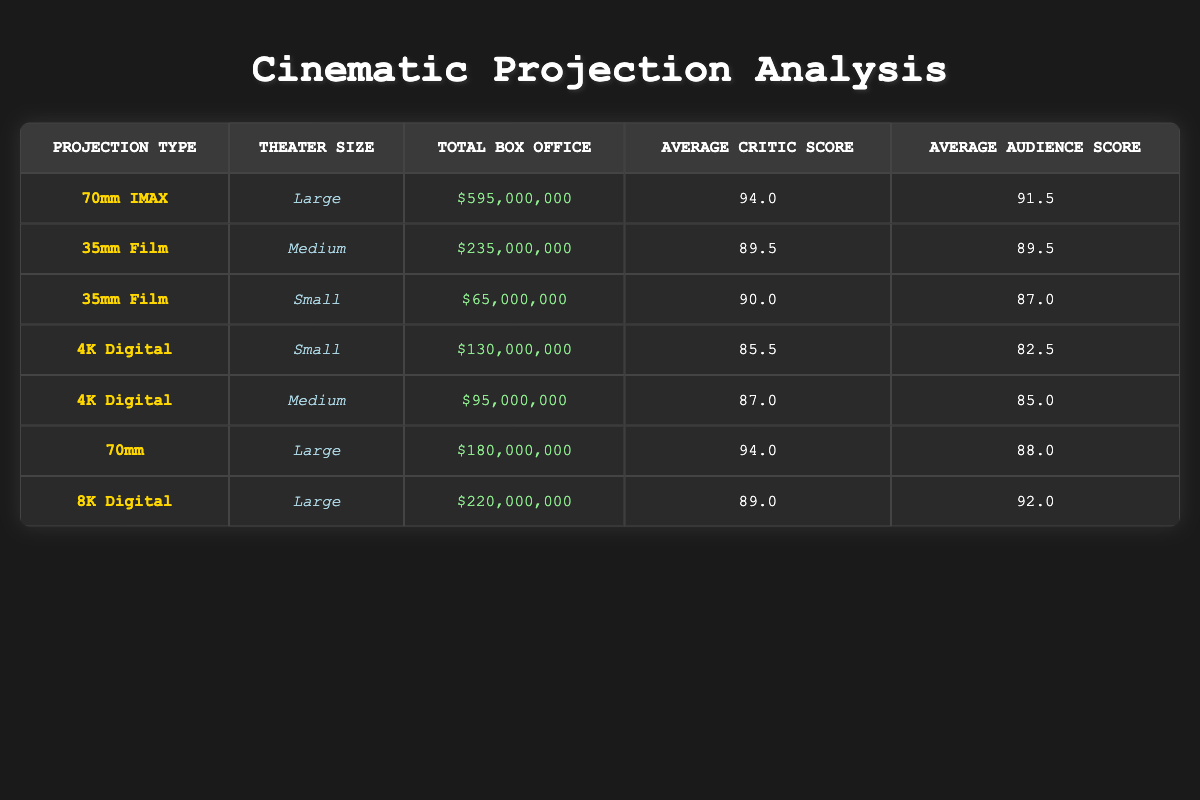What is the total box office for films projected in 70mm IMAX? Only one row in the table corresponds to the 70mm IMAX projection type. That row shows a total box office of $595,000,000.
Answer: $595,000,000 What is the average audience score for films shown in small theaters? There are two projection types for small theaters: 35mm Film (with an audience score of 87) and 4K Digital (with an audience score of 82). To find the average, sum the scores (87 + 82 = 169) and divide by the number of films (2): 169 / 2 = 84.5.
Answer: 84.5 Is the average critic score for films projected in 35mm Film higher than 90? The table has two entries for 35mm Film: one in medium theaters with a critic score of 89.5 and one in small with a score of 90. The average of these two scores is (89.5 + 90) / 2 = 89.75, which is less than 90.
Answer: No Which projection type has the highest total box office, and what is the amount? The highest total box office is found for the 70mm IMAX projection type, which totals $595,000,000 when adding both rows for that projection type.
Answer: 70mm IMAX: $595,000,000 What is the difference in total box office between films projected in 4K Digital and 35mm Film? The total box office for 4K Digital (small + medium) is $225,000,000 (130 + 95), and for 35mm Film (medium + small) is $300,000,000 (235 + 65). The difference is calculated as $300,000,000 - $225,000,000 = $75,000,000.
Answer: $75,000,000 